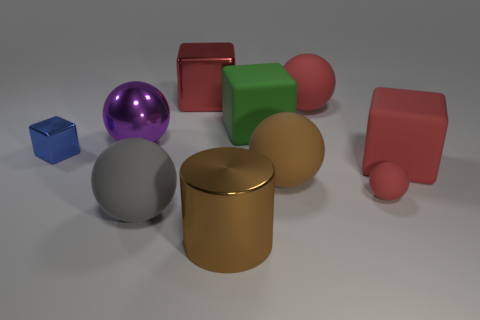Are there any small metallic spheres of the same color as the large metal cylinder?
Ensure brevity in your answer.  No. There is a red rubber cube; does it have the same size as the matte thing to the left of the red metal object?
Provide a succinct answer. Yes. What number of large matte spheres are behind the rubber sphere behind the red cube that is on the right side of the cylinder?
Your answer should be very brief. 0. There is a big shiny cylinder; what number of tiny matte objects are in front of it?
Provide a short and direct response. 0. What color is the large metallic thing that is in front of the big matte ball to the left of the big metallic cube?
Provide a succinct answer. Brown. What number of other things are made of the same material as the big purple object?
Provide a short and direct response. 3. Are there the same number of metal things behind the small blue object and large brown things?
Offer a terse response. Yes. What is the material of the brown thing in front of the big matte sphere that is on the left side of the big block that is on the left side of the big brown metallic cylinder?
Offer a very short reply. Metal. The big thing that is in front of the large gray matte sphere is what color?
Your response must be concise. Brown. Is there any other thing that has the same shape as the green object?
Ensure brevity in your answer.  Yes. 